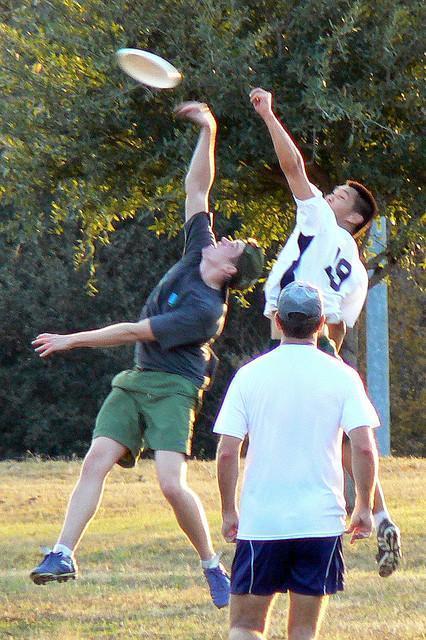How many players are in the air?
Give a very brief answer. 2. How many people can you see?
Give a very brief answer. 3. 